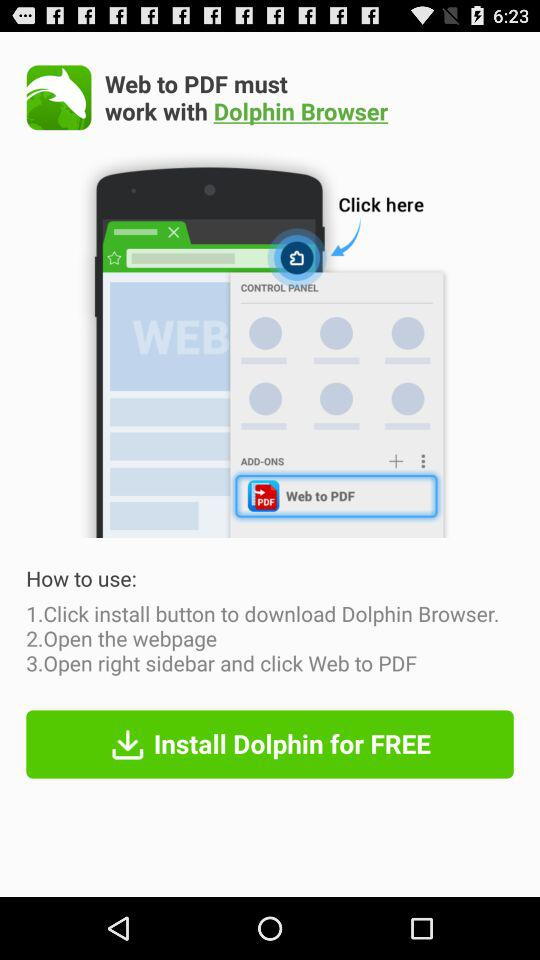How many steps are there to use Web to PDF?
Answer the question using a single word or phrase. 3 